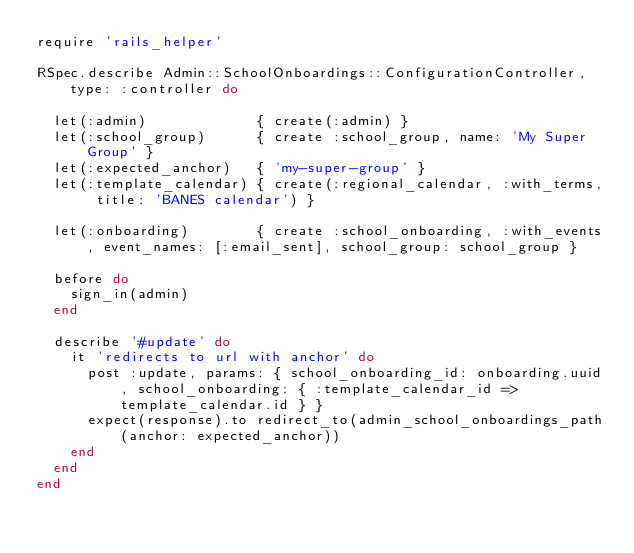Convert code to text. <code><loc_0><loc_0><loc_500><loc_500><_Ruby_>require 'rails_helper'

RSpec.describe Admin::SchoolOnboardings::ConfigurationController, type: :controller do

  let(:admin)             { create(:admin) }
  let(:school_group)      { create :school_group, name: 'My Super Group' }
  let(:expected_anchor)   { 'my-super-group' }
  let(:template_calendar) { create(:regional_calendar, :with_terms, title: 'BANES calendar') }

  let(:onboarding)        { create :school_onboarding, :with_events, event_names: [:email_sent], school_group: school_group }

  before do
    sign_in(admin)
  end

  describe '#update' do
    it 'redirects to url with anchor' do
      post :update, params: { school_onboarding_id: onboarding.uuid, school_onboarding: { :template_calendar_id => template_calendar.id } }
      expect(response).to redirect_to(admin_school_onboardings_path(anchor: expected_anchor))
    end
  end
end
</code> 